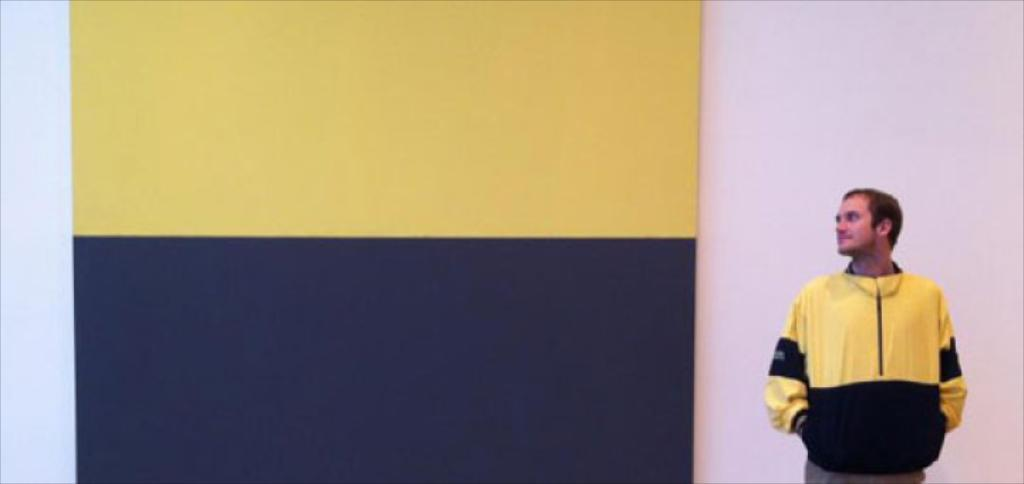What can be seen in the background of the image? There is a wall in the image. Who is present in the image? There is a man in the image. What is the man wearing? The man is wearing a yellow jacket. What type of record is the man holding in the image? There is no record present in the image; the man is wearing a yellow jacket and standing in front of a wall. What kind of experience does the man have with the van in the image? There is no van present in the image, so it is not possible to determine any experience the man might have with a van. 